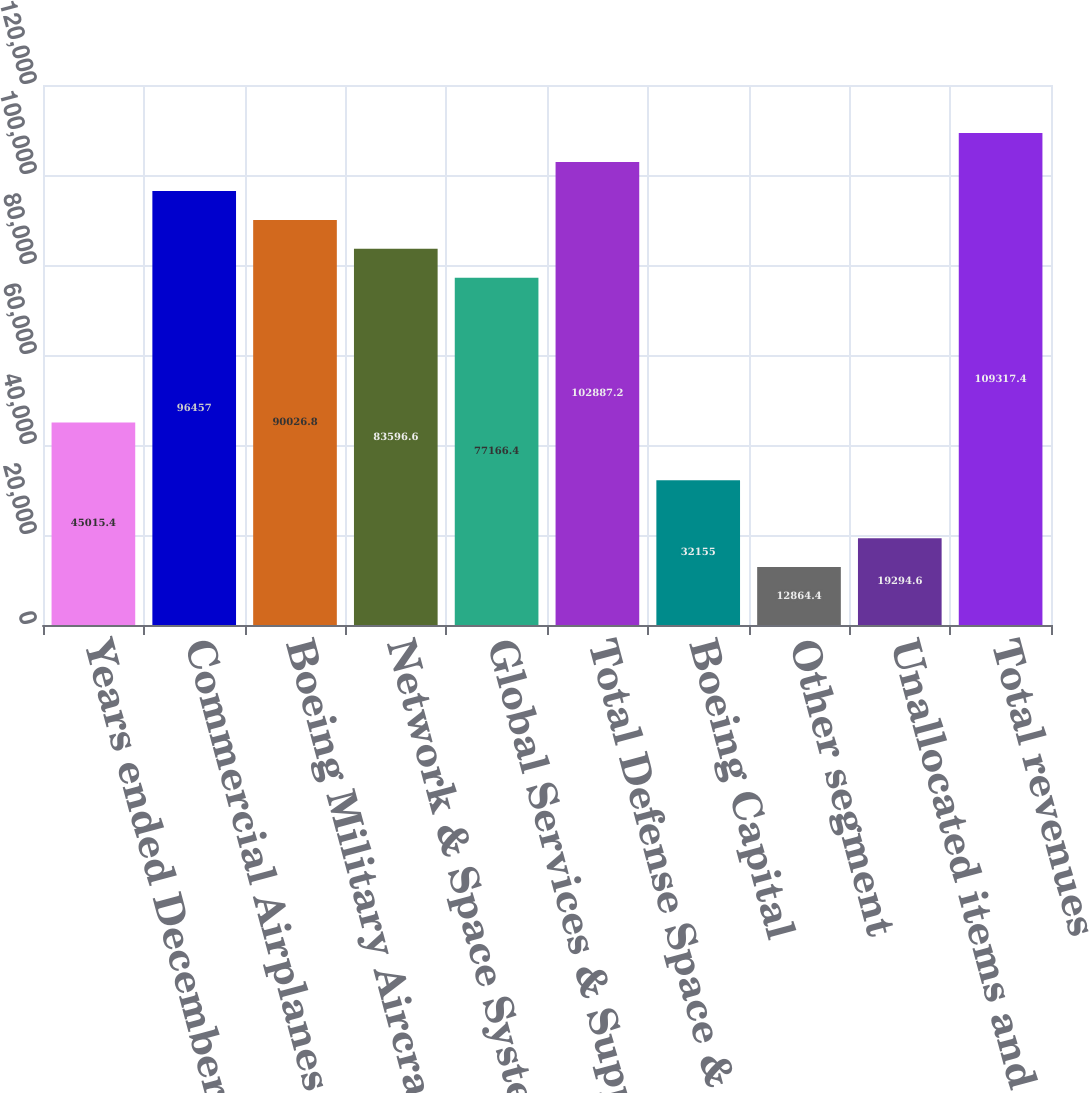<chart> <loc_0><loc_0><loc_500><loc_500><bar_chart><fcel>Years ended December 31<fcel>Commercial Airplanes<fcel>Boeing Military Aircraft<fcel>Network & Space Systems<fcel>Global Services & Support<fcel>Total Defense Space & Security<fcel>Boeing Capital<fcel>Other segment<fcel>Unallocated items and<fcel>Total revenues<nl><fcel>45015.4<fcel>96457<fcel>90026.8<fcel>83596.6<fcel>77166.4<fcel>102887<fcel>32155<fcel>12864.4<fcel>19294.6<fcel>109317<nl></chart> 